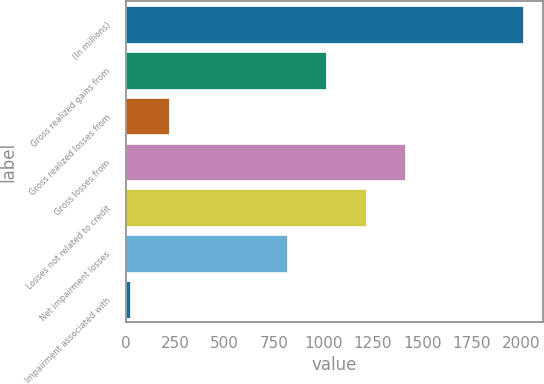<chart> <loc_0><loc_0><loc_500><loc_500><bar_chart><fcel>(In millions)<fcel>Gross realized gains from<fcel>Gross realized losses from<fcel>Gross losses from<fcel>Losses not related to credit<fcel>Net impairment losses<fcel>Impairment associated with<nl><fcel>2009<fcel>1015.5<fcel>220.7<fcel>1412.9<fcel>1214.2<fcel>816.8<fcel>22<nl></chart> 